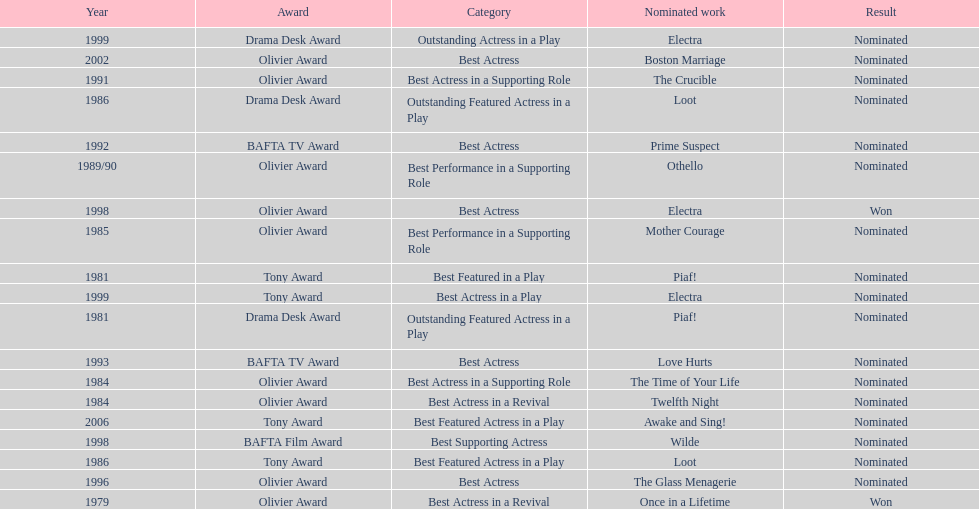What play was wanamaker nominated for best featured in a play in 1981? Piaf!. 